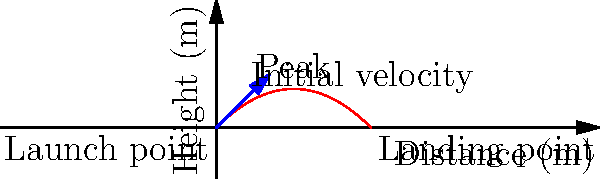In a high-budget action film being shot in the Australian Outback, a stunt coordinator needs to calculate the range of a projectile launched from a special effects rig. The projectile is launched with an initial velocity of 20 m/s at an angle of 45° above the horizontal. Assuming negligible air resistance, what is the horizontal distance traveled by the projectile before it lands? Let's approach this step-by-step:

1) The range of a projectile launched at an angle can be calculated using the formula:

   $R = \frac{v_0^2 \sin(2\theta)}{g}$

   Where $R$ is the range, $v_0$ is the initial velocity, $\theta$ is the launch angle, and $g$ is the acceleration due to gravity.

2) We're given:
   $v_0 = 20$ m/s
   $\theta = 45°$ (which is $\pi/4$ radians)
   $g = 9.8$ m/s² (standard gravity)

3) Let's substitute these values:

   $R = \frac{(20)^2 \sin(2 \cdot 45°)}{9.8}$

4) Simplify:
   $\sin(2 \cdot 45°) = \sin(90°) = 1$

   So, $R = \frac{400 \cdot 1}{9.8}$

5) Calculate:
   $R = 40.82$ m

Therefore, the projectile will travel approximately 40.82 meters horizontally before landing.
Answer: 40.82 meters 